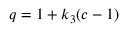<formula> <loc_0><loc_0><loc_500><loc_500>q = 1 + k _ { 3 } ( c - 1 )</formula> 